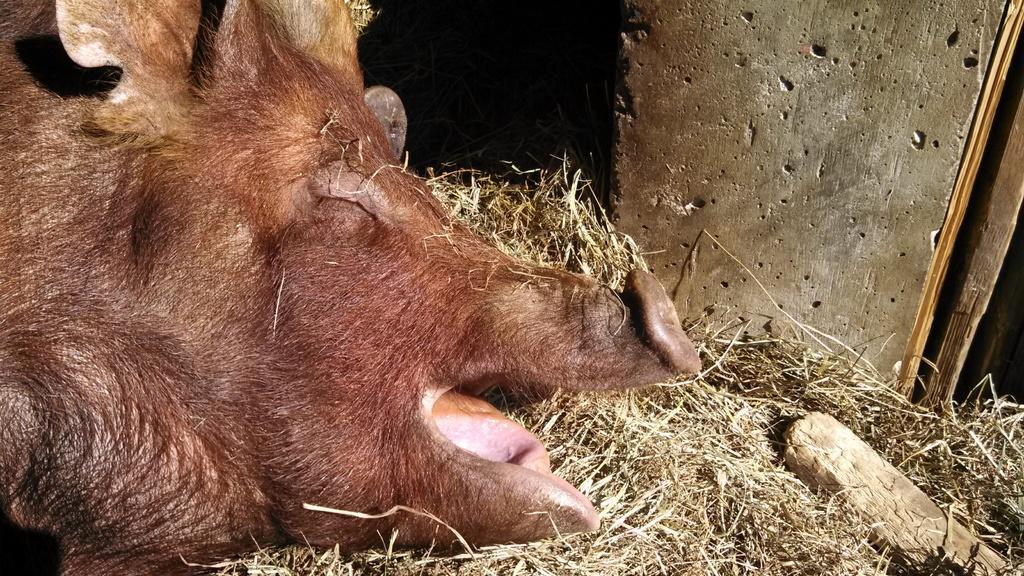In one or two sentences, can you explain what this image depicts? This image is taken outdoors. On the right side of the image there is a wall. On the left side of the image there is a pig lying on the ground. At the bottom of the image there grass and a wooden piece. 